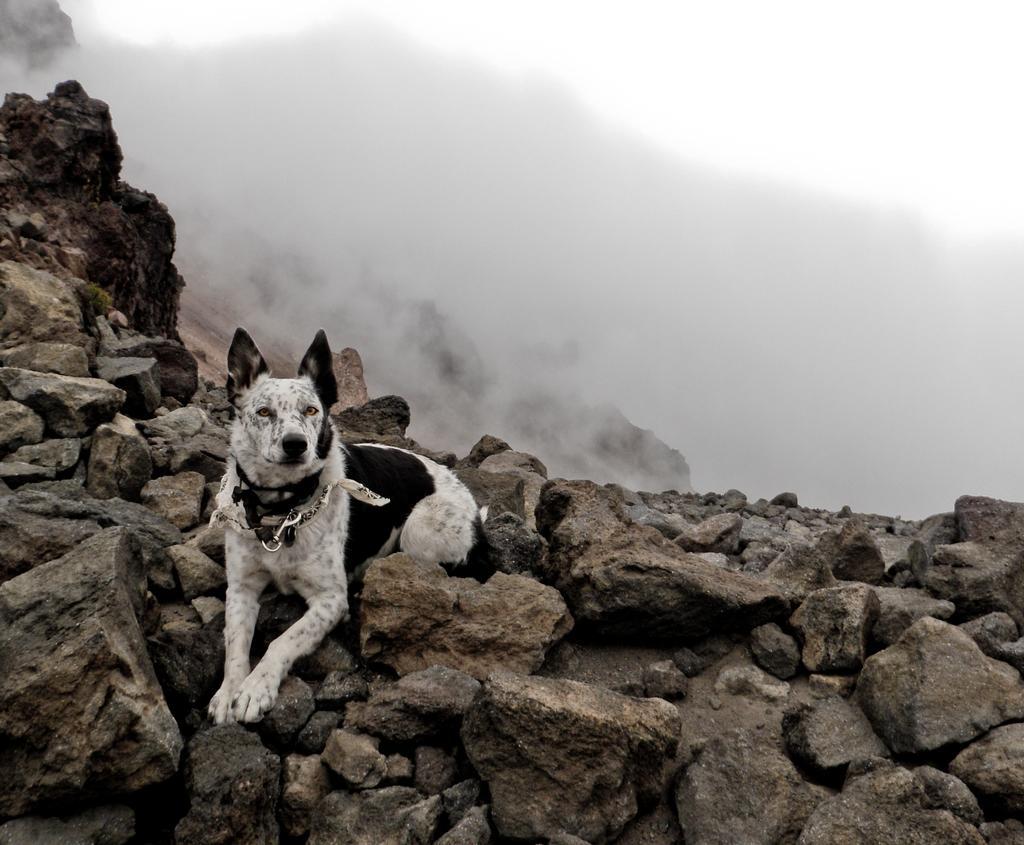How would you summarize this image in a sentence or two? In this picture there is a dog on the rocks, on the left side of the image and there are rocks at the bottom side of the image, there is smoke at the top side of the image. 